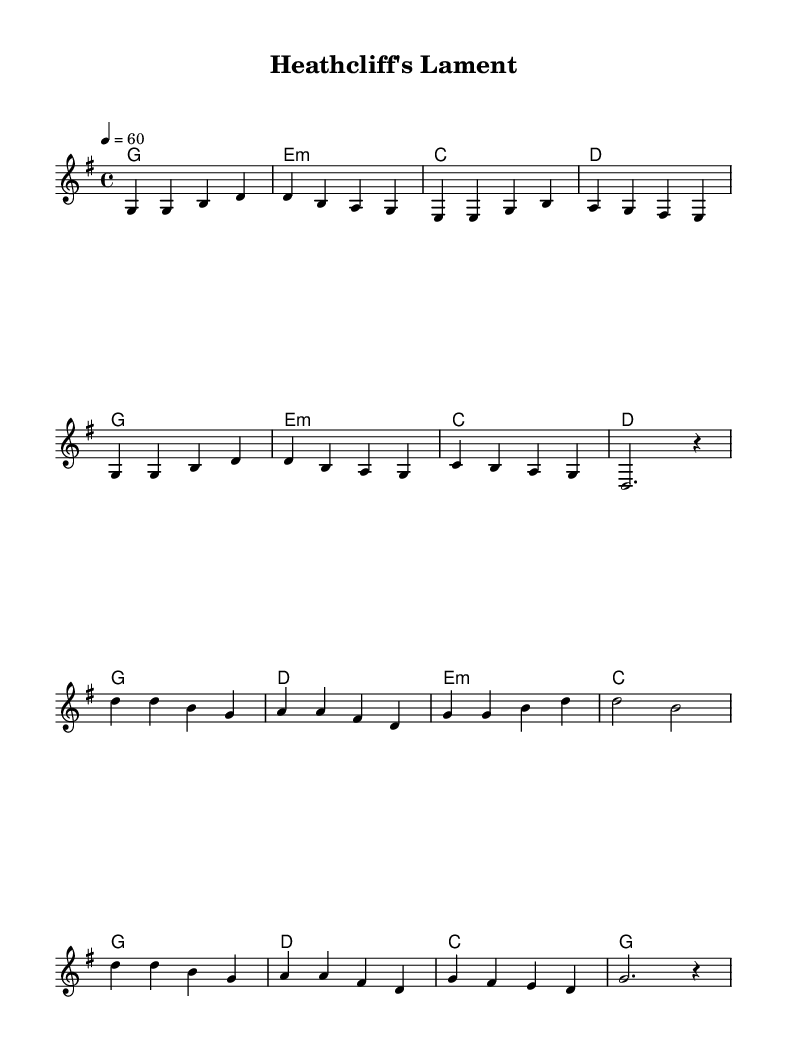What is the key signature of this music? The key signature shows one sharp (F#), indicating G major.
Answer: G major What is the time signature of this composition? The time signature is indicated at the beginning as 4/4, meaning four beats per measure.
Answer: 4/4 What tempo marking is specified in the score? The score specifies a tempo of quarter note equals 60 beats per minute.
Answer: 60 How many verses are present in the music? There is only one verse provided in the score.
Answer: One What literary work does this ballad reference? The lyrics refer to "Wuthering Heights," a novel by Emily Brontë.
Answer: Wuthering Heights In the chorus, what two themes are particularly highlighted? The chorus emphasizes the themes of love and loss.
Answer: Love and loss What is the emotional tone suggested by the lyrics and music structure? The tone suggested is mournful, as indicated by the choice of lyrics and harmonic progressions.
Answer: Mournful 